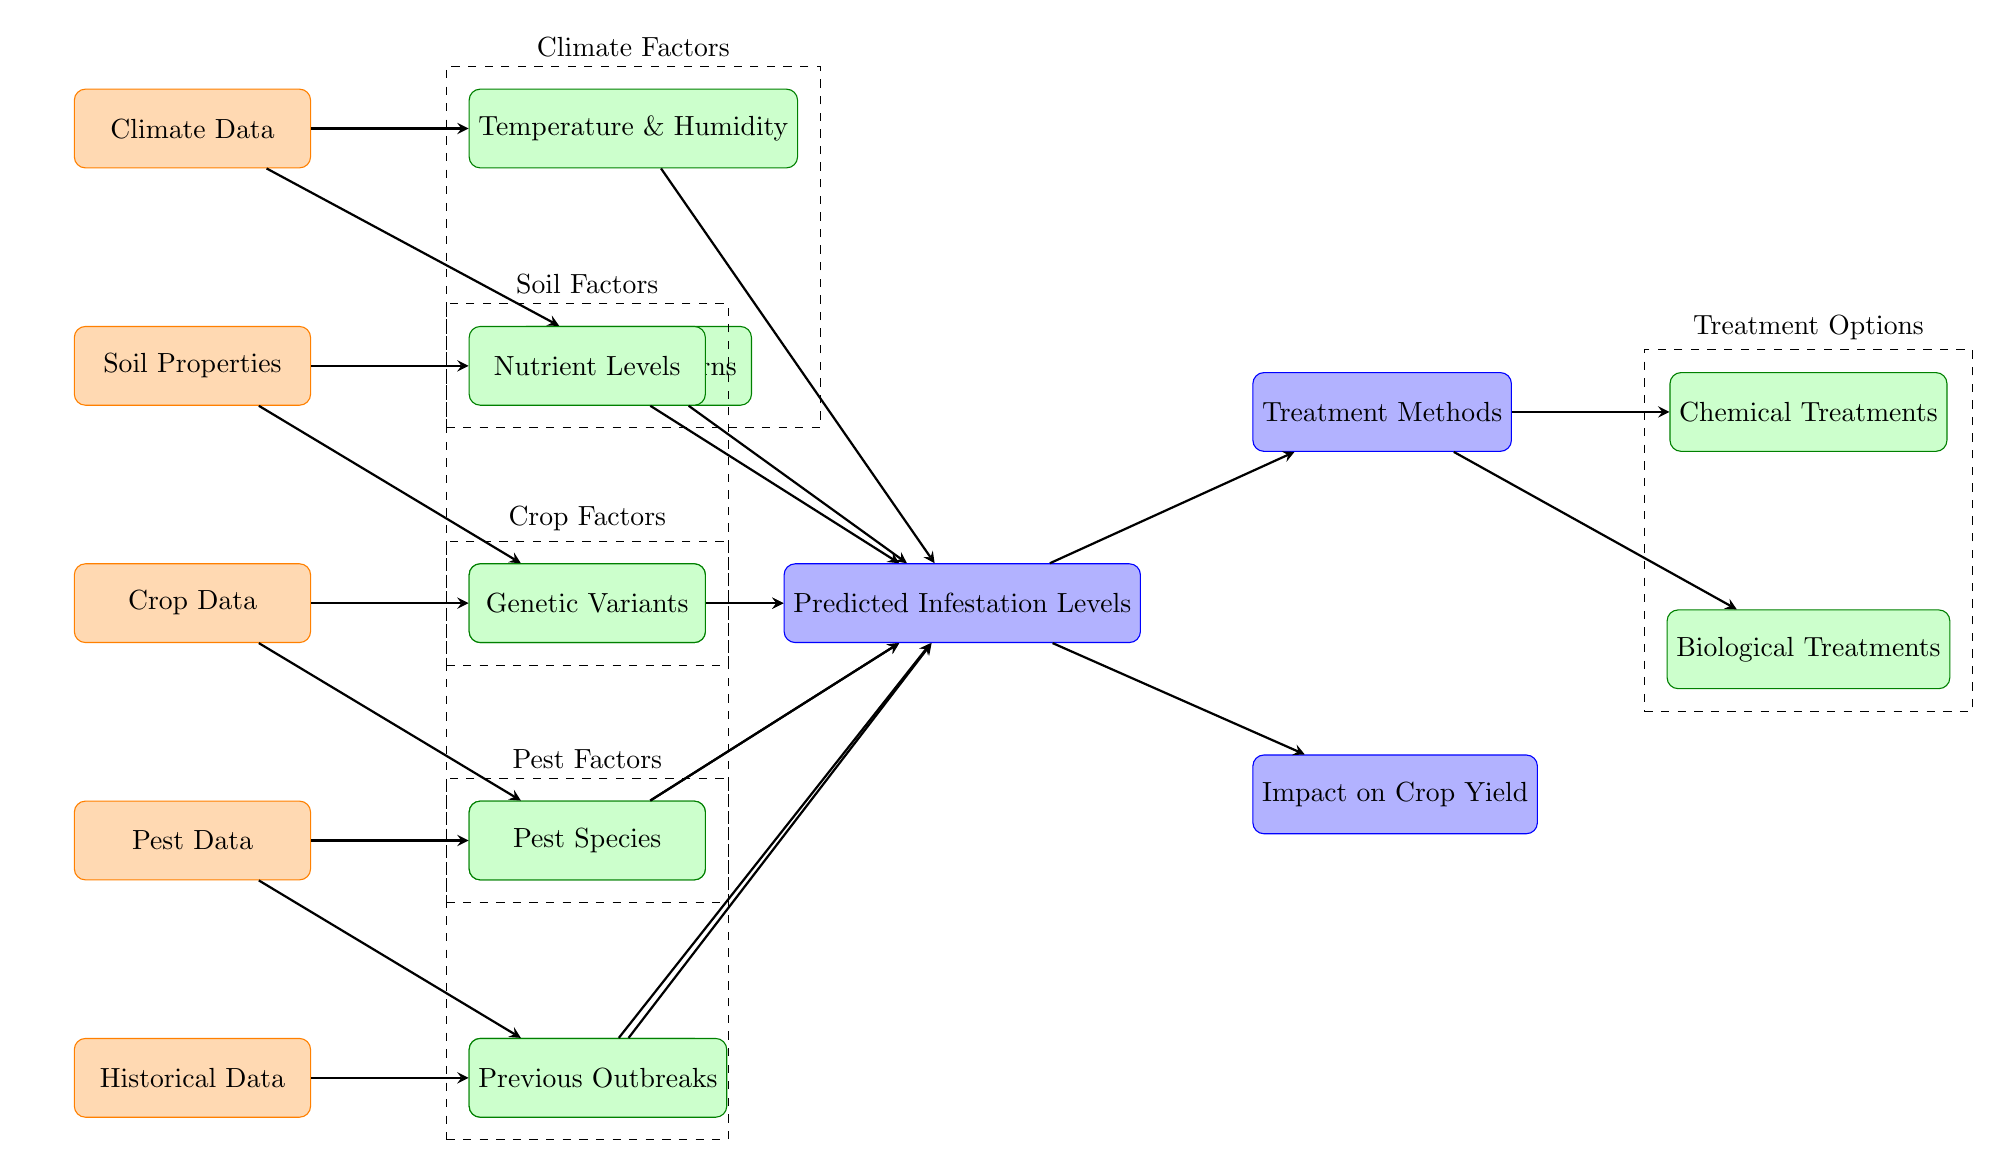What are the input factors in this model? The model has five input factors: Climate Data, Soil Properties, Crop Data, Pest Data, and Historical Data. These are visualized on the left side of the diagram.
Answer: Climate Data, Soil Properties, Crop Data, Pest Data, Historical Data How many process nodes are there? The diagram displays nine process nodes, which include Temperature & Humidity, Rainfall Patterns, Nutrient Levels, pH Levels, Genetic Variants, Growth Stages, Pest Species, Pest Life Cycle, and Previous Outbreaks.
Answer: 9 What node directly connects to "Predicted Infestation Levels"? The Predicted Infestation Levels node is directly connected to Temperature & Humidity, Rainfall Patterns, Nutrient Levels, pH Levels, Genetic Variants, Growth Stages, Pest Species, Pest Life Cycle, and Previous Outbreaks, indicating multiple influences.
Answer: Multiple nodes Which group contains the node "Chemical Treatments"? The Chemical Treatments node is contained within the Treatment Options group. This group is outlined in dashed lines, indicating that it encompasses different treatment methods.
Answer: Treatment Options What is the output related to crop yield? The output related to crop yield is "Impact on Crop Yield." This is shown directly below the Predicted Infestation Levels node, indicating its dependency on infestation prediction.
Answer: Impact on Crop Yield Which factors influence the predicted infestation levels? The Predicted Infestation Levels are influenced by Climate Factors, Soil Factors, Crop Factors, and Pest Factors, as derived from the arrows pointing towards the infestation node from these groups.
Answer: Climate, Soil, Crop, Pest How many treatment methods are listed in the diagram? There are two treatment methods listed in the diagram: Chemical Treatments and Biological Treatments, both of which are sub-nodes under Treatment Methods.
Answer: 2 What is the relationship between "Infestation" and "Yield"? The relationship is that the predicted infestation levels directly impact the crop yield, meaning that higher levels of infestation may lead to a decrease in yield. This is indicated by the arrow pointing from the Infestation node to the Yield node.
Answer: Infestation impacts Yield Which node is connected to the "Pest Species" node? The node connected to the Pest Species is "Pest Data." This relationship indicates that pest data provides input regarding which species of pests are present in the model.
Answer: Pest Data 